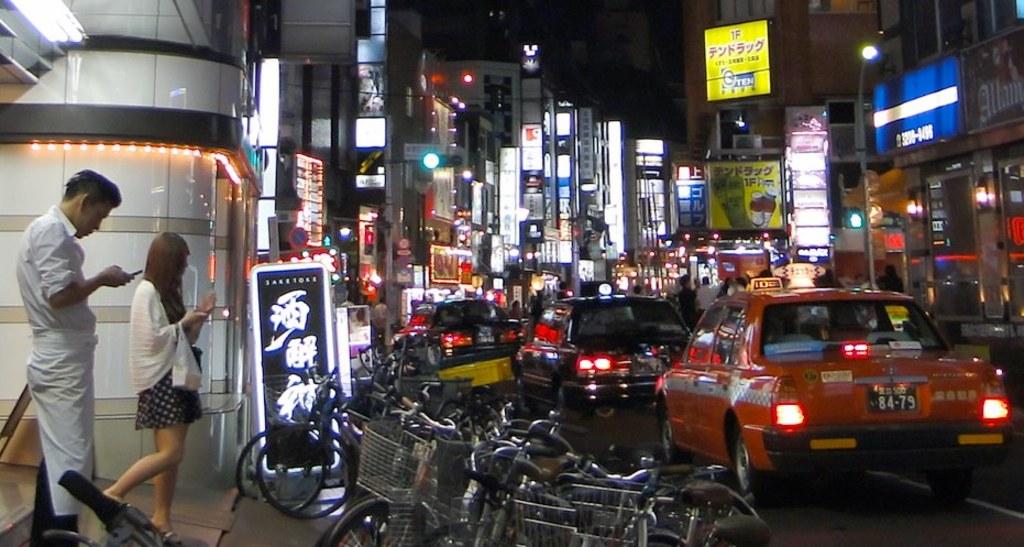What numbers are on the back of the cab?
Provide a succinct answer. 84-79. 